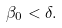Convert formula to latex. <formula><loc_0><loc_0><loc_500><loc_500>\beta _ { 0 } < \delta .</formula> 